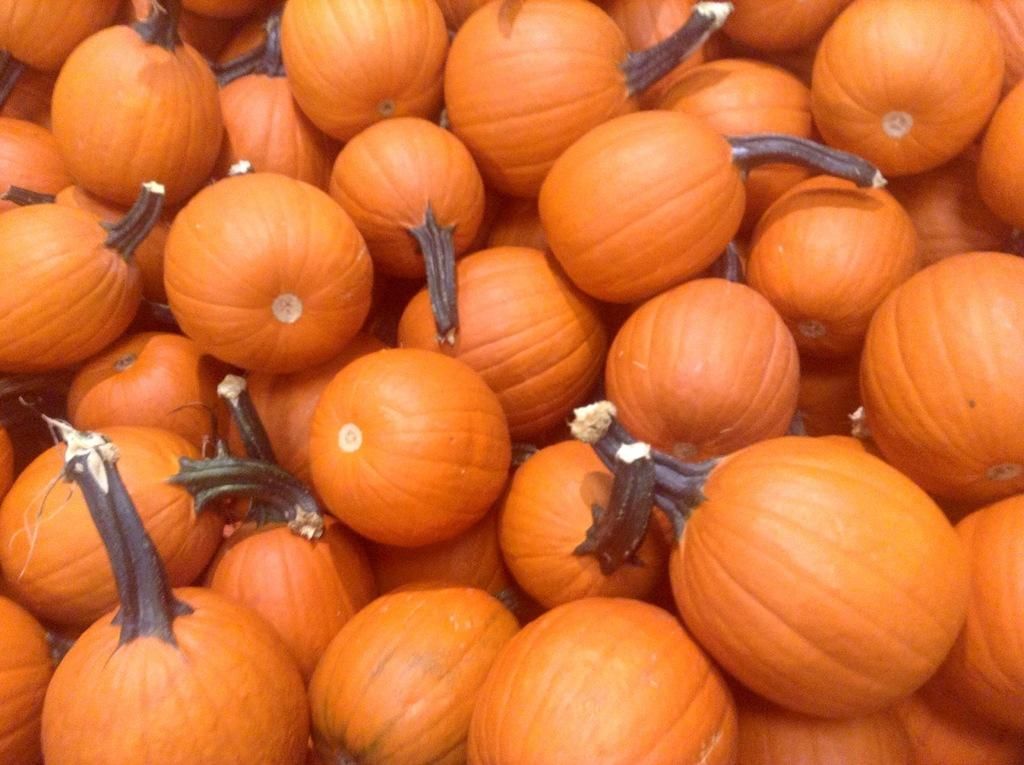What type of objects are present in the image? There are pumpkins in the image. Can you describe the appearance of the pumpkins? The pumpkins appear to be round and orange in color. Are there any other objects or elements in the image besides the pumpkins? The provided facts do not mention any other objects or elements in the image. What type of books are being advertised in the image? There are no books or advertisements present in the image; it only features pumpkins. Is there a letter addressed to someone in the image? There is no letter or any form of written communication present in the image; it only features pumpkins. 